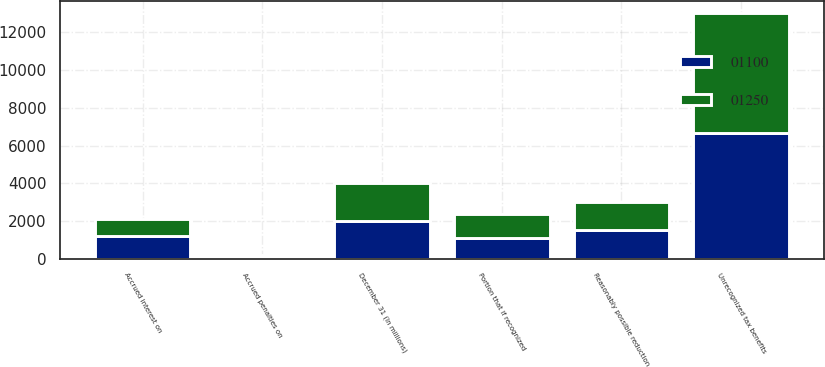<chart> <loc_0><loc_0><loc_500><loc_500><stacked_bar_chart><ecel><fcel>December 31 (In millions)<fcel>Unrecognized tax benefits<fcel>Portion that if recognized<fcel>Accrued interest on<fcel>Accrued penalties on<fcel>Reasonably possible reduction<nl><fcel>1100<fcel>2008<fcel>6692<fcel>1100<fcel>1204<fcel>96<fcel>1500<nl><fcel>1250<fcel>2007<fcel>6331<fcel>1250<fcel>923<fcel>77<fcel>1500<nl></chart> 